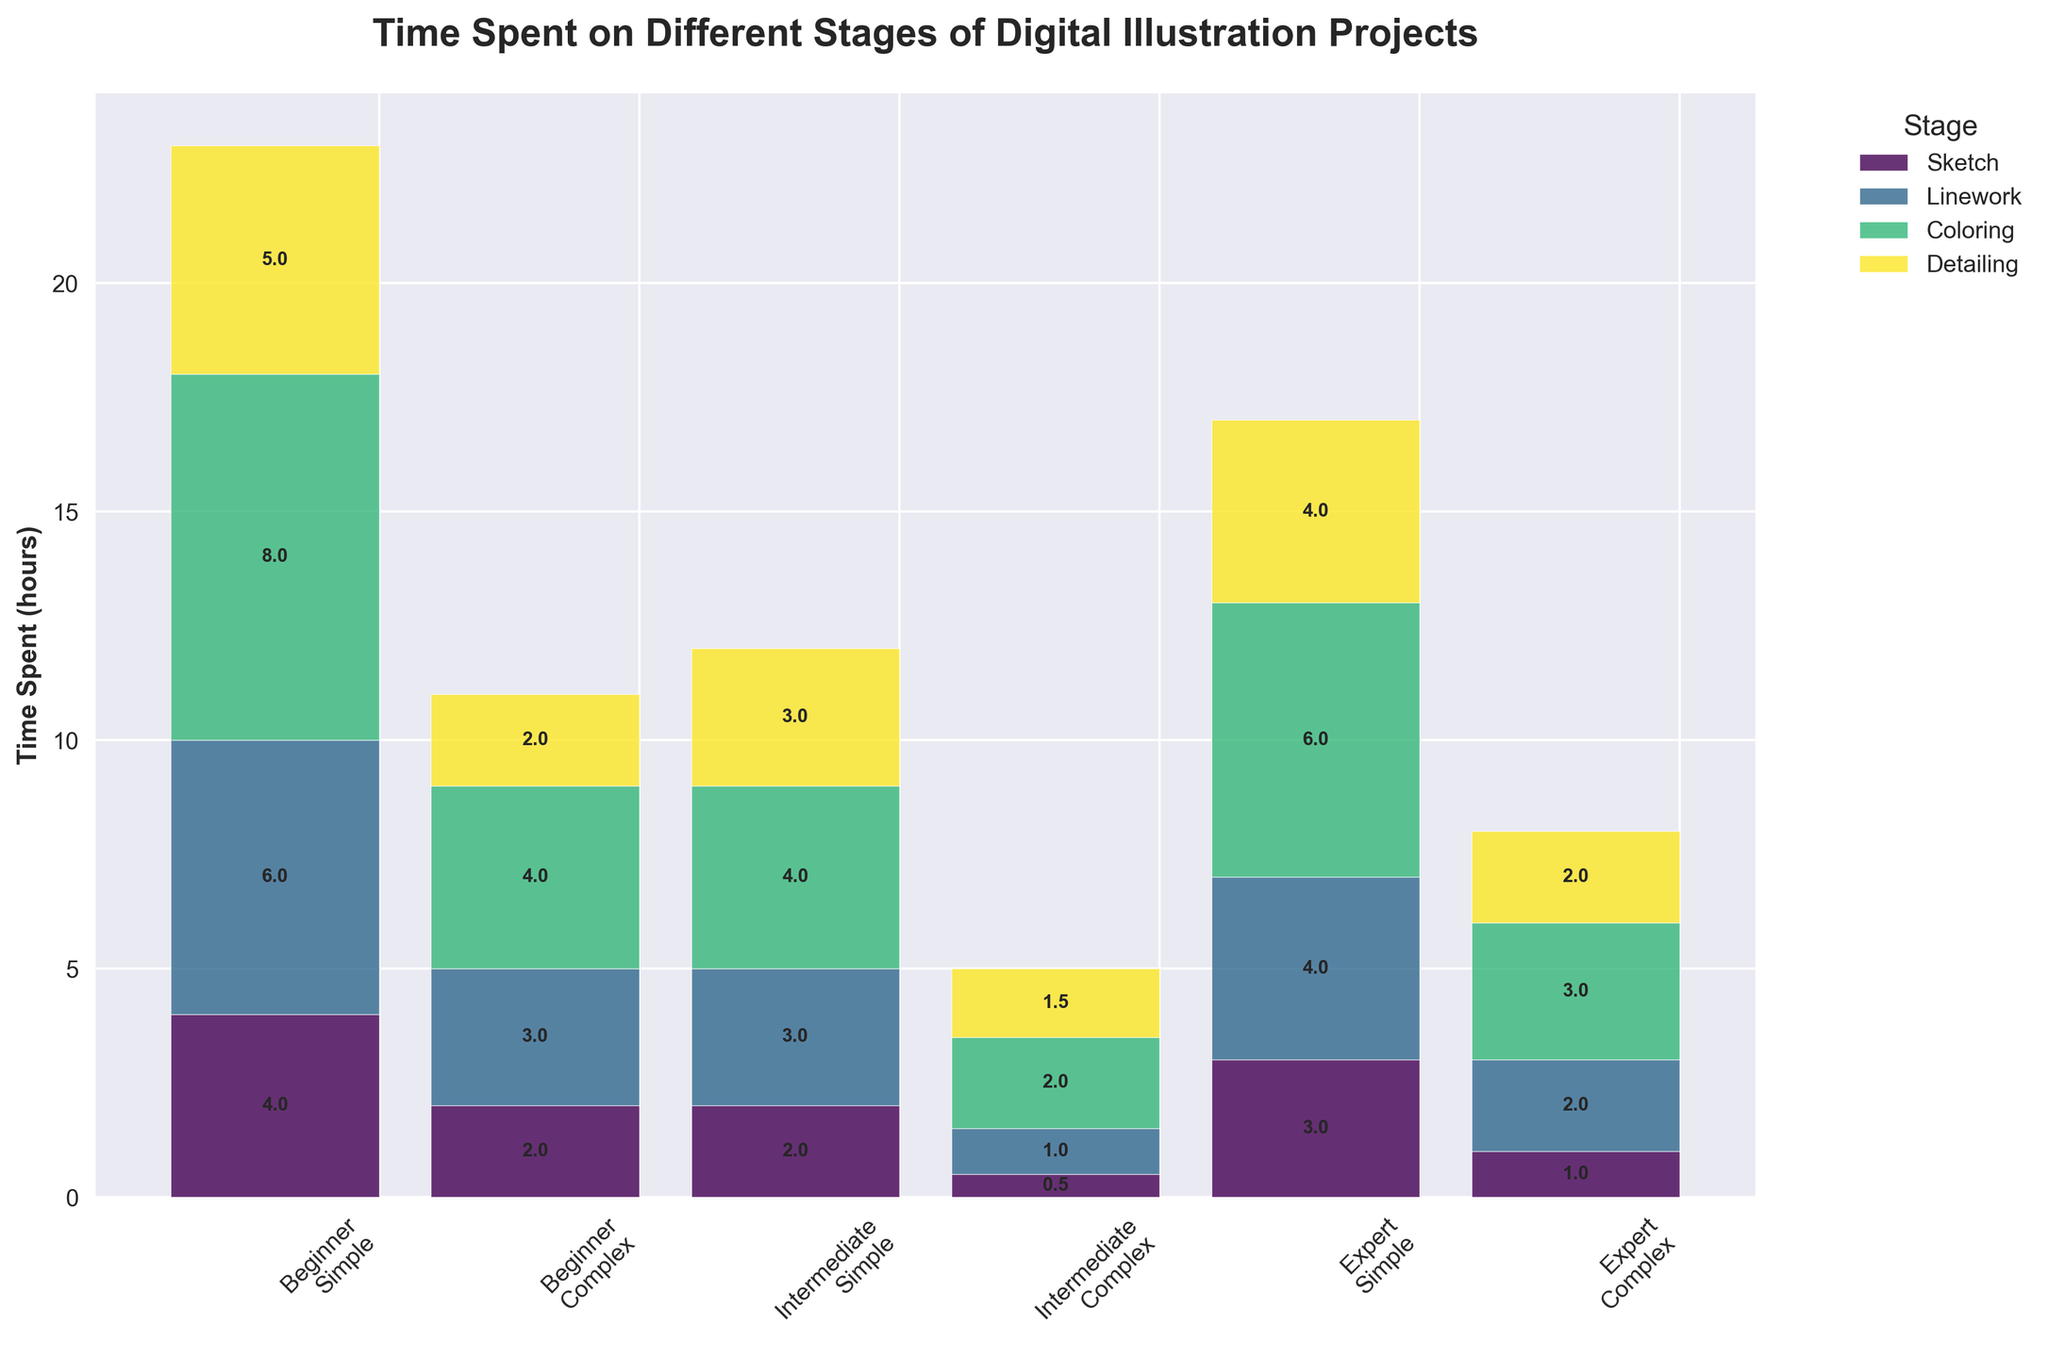How many experience levels are being compared? We can see that there are three unique experience levels indicated by the x-ticks labels: Beginner, Intermediate, and Expert.
Answer: 3 What is the title of the figure? The title of the figure is displayed at the top of the plot, indicating the main subject of the visualized data.
Answer: Time Spent on Different Stages of Digital Illustration Projects Which stage takes the most time for Beginners working on complex artwork? By examining the heights of the bars for each stage under 'Beginner - Complex', we see that 'Coloring' has the tallest bar.
Answer: Coloring Who spends less time on detailing a simple artwork, Beginners or Experts? By comparing the 'Detailing' bars for 'Simple' artwork between Beginners and Experts, we see that the bar for Experts is shorter.
Answer: Experts What is the total time spent by Intermediate illustrators on all stages of complex artwork? For Intermediate and Complex artworks, sum up the heights of the bars for each stage: Sketch (3) + Linework (4) + Coloring (6) + Detailing (4) = 17 hours.
Answer: 17 hours Between Experts and Beginners, who spends more time on linework for complex projects? By comparing the heights of the 'Linework' bars under 'Complex' projects for both Beginners and Experts, the Beginner bar is taller.
Answer: Beginners How much more time does a Beginner spend on sketching complex artwork compared to simple artwork? For Beginners, the time for Sketching in complex artwork is 4 hours, and for simple artwork, it is 2 hours. The difference is 4 - 2 = 2 hours.
Answer: 2 hours What is the average time spent on coloring by Intermediate illustrators across both complexity levels? Summing the time spent on Coloring by Intermediate for Simple (3) and Complex (6) artwork gives 3 + 6 = 9 hours. The average is 9/2 = 4.5 hours.
Answer: 4.5 hours Which group spends the least amount of time on sketching, taking both complexities into account? By comparing the total height of the 'Sketch' bars for each group across both complexities, the Expert group with times of 0.5 and 2 hours (total 2.5 hours) spends the least.
Answer: Experts 